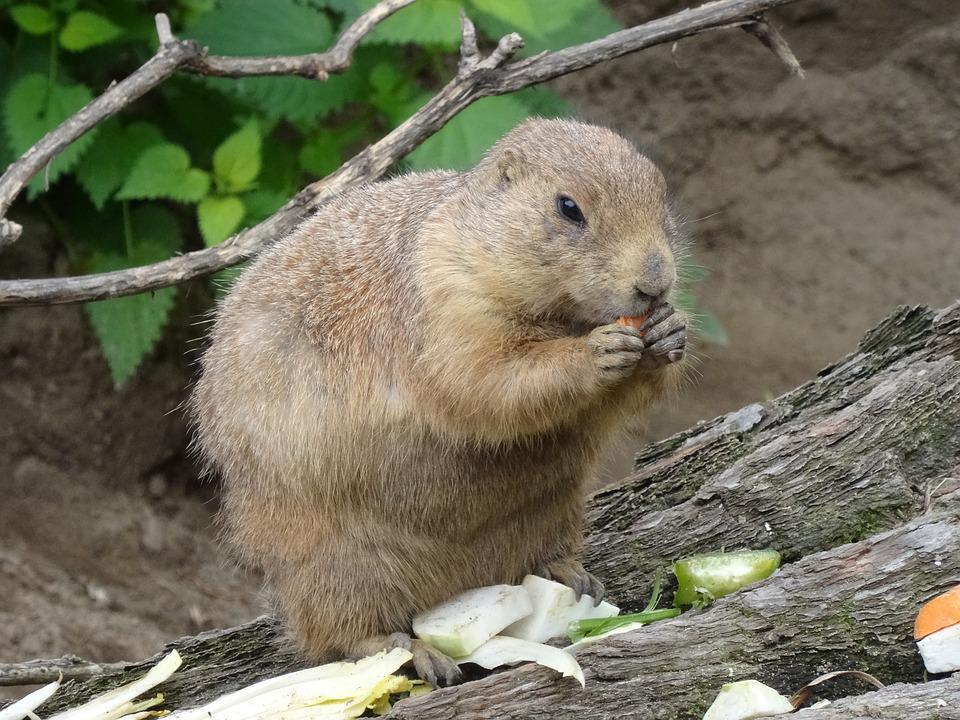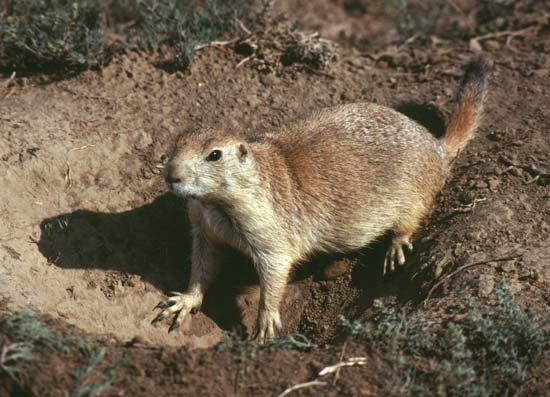The first image is the image on the left, the second image is the image on the right. Considering the images on both sides, is "The marmot in the left image is upright with food clasped in its paws, and the marmot on the right is standing on all fours on the ground." valid? Answer yes or no. Yes. The first image is the image on the left, the second image is the image on the right. Given the left and right images, does the statement "The animal in the image on the left is holding something to its mouth." hold true? Answer yes or no. Yes. 